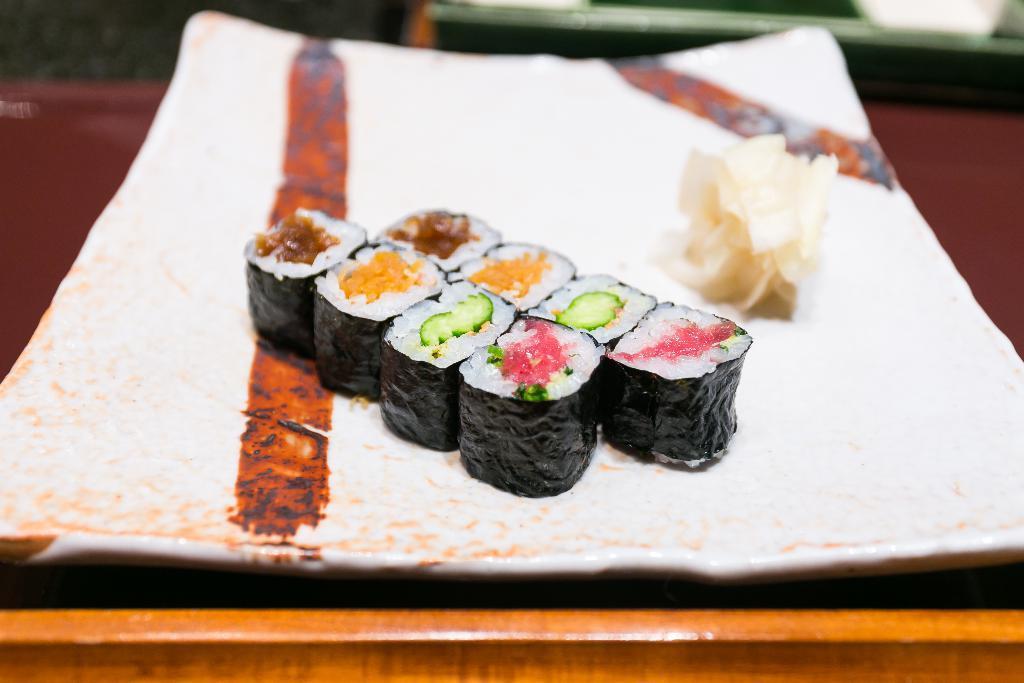Describe this image in one or two sentences. In this picture, we can see some food items served on a plate and kept on an object, we can see the blurred background. 